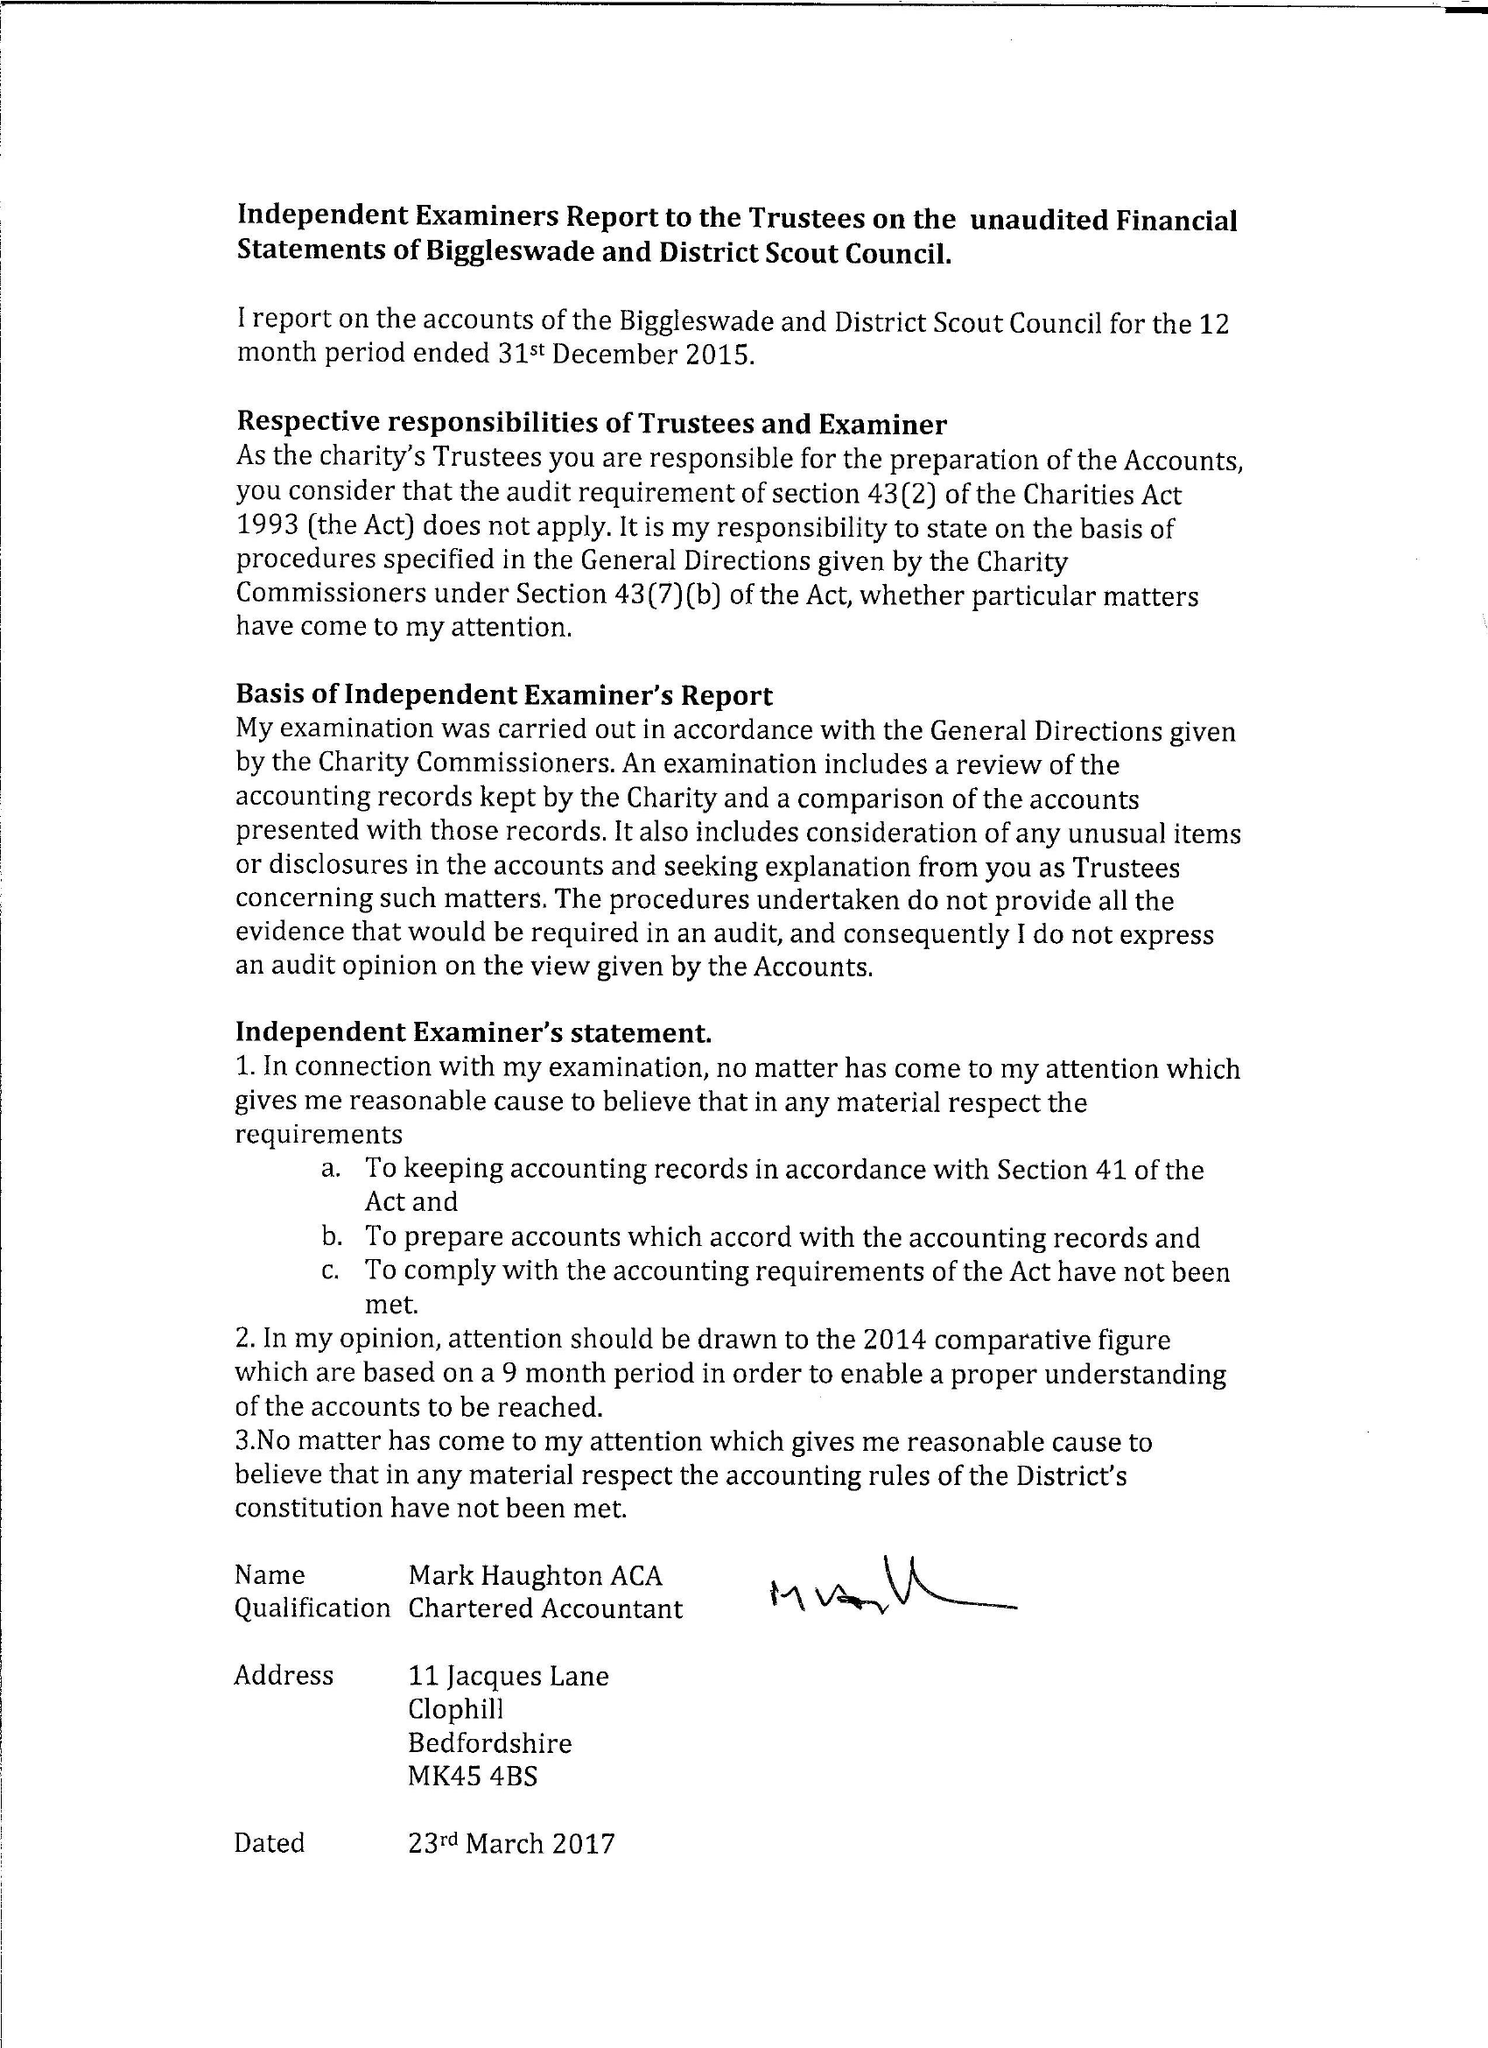What is the value for the charity_number?
Answer the question using a single word or phrase. 300458 